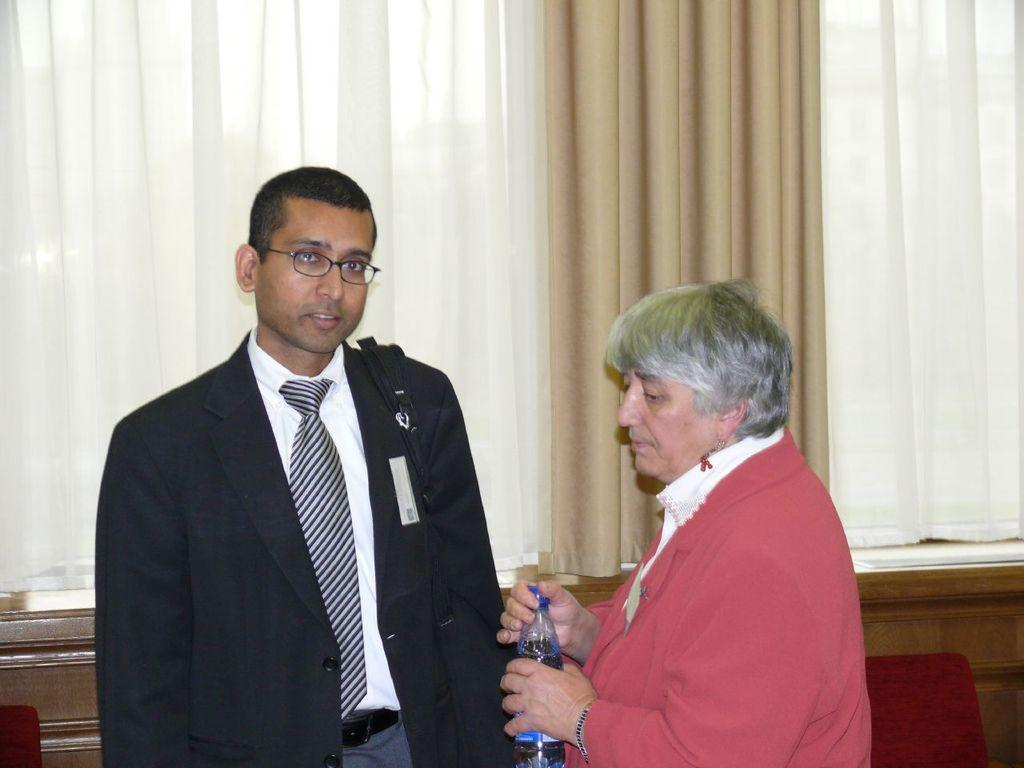What is the man in the image wearing? The man in the image is wearing a suit. What is the man doing in the image? The man is posing for the camera. Who is standing beside the man in the image? There is an old woman standing beside the man in the image. What is the old woman holding in her hand? The old woman is holding a bottle in her hand. What type of acoustics can be heard in the image? There is no sound or acoustics present in the image, as it is a still photograph. 